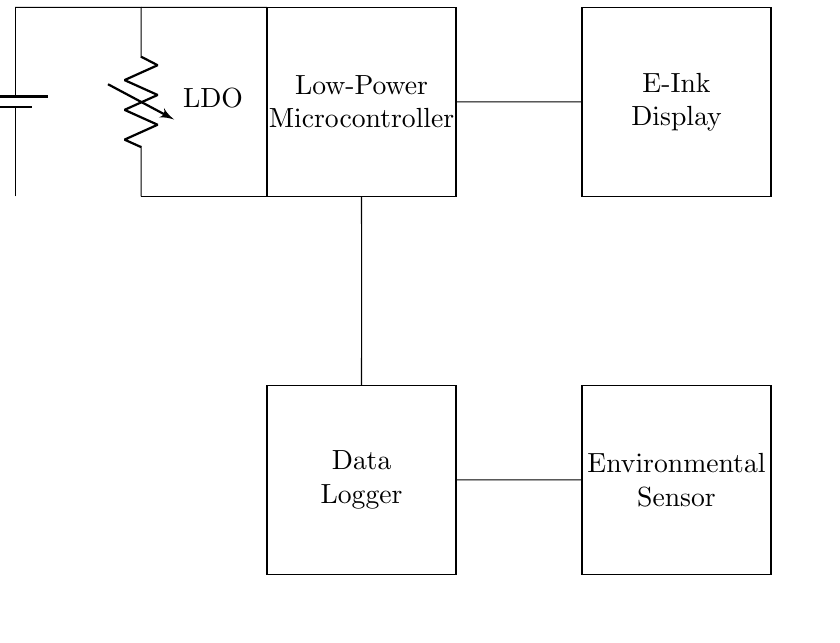what type of battery is used in this circuit? The circuit shows a Li-Ion battery, which is commonly used for its high energy density and rechargeable capabilities in low-power applications.
Answer: Li-Ion what is the output voltage of the battery? The battery is labeled as providing 3.7 volts, which indicates the voltage it supplies to the circuit.
Answer: 3.7 volts what component is connected to the battery? The voltage regulator is connected directly to the battery, ensuring a stable output voltage for the rest of the circuit components.
Answer: Voltage regulator how many data logging components are present? There is one data logger shown in the circuit, which is responsible for recording the environmental data captured by the sensor for further analysis.
Answer: One what type of display is used in the circuit? The circuit uses an E-Ink display, known for its low power consumption, which makes it suitable for battery-operated devices, like this portable survey device.
Answer: E-Ink display how does the microcontroller receive power? The microcontroller receives power directly from the voltage regulator, which converts the battery voltage to the operating voltage needed for the microcontroller.
Answer: From the voltage regulator what is the function of the environmental sensor in this circuit? The environmental sensor measures various environmental parameters, such as temperature or humidity, and sends this data to the data logger for recording and analysis within the survey device.
Answer: Measurement 